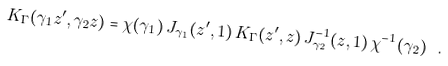<formula> <loc_0><loc_0><loc_500><loc_500>K _ { \Gamma } ( \gamma _ { 1 } z ^ { \prime } , \gamma _ { 2 } z ) = \chi ( \gamma _ { 1 } ) \, J _ { \gamma _ { 1 } } ( z ^ { \prime } , 1 ) \, K _ { \Gamma } ( z ^ { \prime } , z ) \, J _ { \gamma _ { 2 } } ^ { - 1 } ( z , 1 ) \, \chi ^ { - 1 } ( \gamma _ { 2 } ) \ .</formula> 